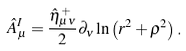<formula> <loc_0><loc_0><loc_500><loc_500>\hat { A } _ { \mu } ^ { I } = \frac { \hat { \eta } _ { \mu \nu } ^ { + } } 2 \partial _ { \nu } \ln \left ( r ^ { 2 } + \rho ^ { 2 } \right ) .</formula> 